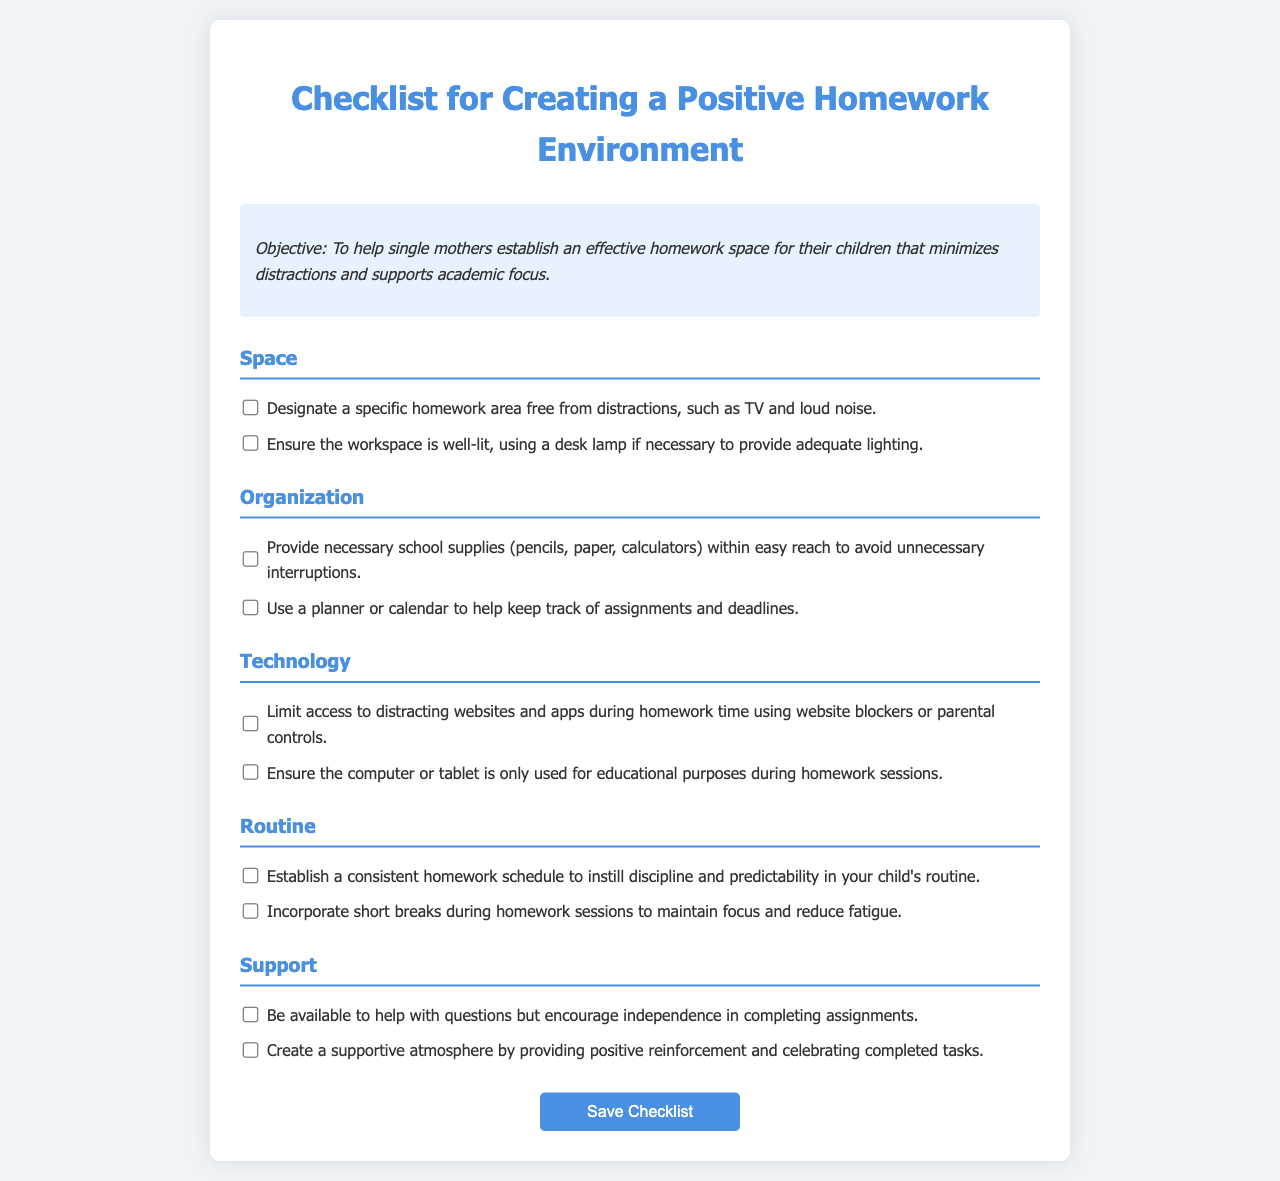What is the objective of the checklist? The objective is to help single mothers establish an effective homework space for their children that minimizes distractions and supports academic focus.
Answer: To help single mothers establish an effective homework space for their children that minimizes distractions and supports academic focus How many categories are included in the checklist? The checklist includes five categories: Space, Organization, Technology, Routine, and Support.
Answer: Five Which category contains the recommendation about using a planner? The recommendation about using a planner is found in the Organization category.
Answer: Organization What should be ensured about the workspace lighting? The workspace should be well-lit, using a desk lamp if necessary to provide adequate lighting.
Answer: Well-lit, using a desk lamp if necessary to provide adequate lighting What is one way to create a supportive atmosphere? One way to create a supportive atmosphere is by providing positive reinforcement and celebrating completed tasks.
Answer: Providing positive reinforcement and celebrating completed tasks What does the routine category suggest about breaks? The routine category suggests incorporating short breaks during homework sessions to maintain focus and reduce fatigue.
Answer: Incorporating short breaks during homework sessions What feature does the submit button have? The submit button has a hover effect that changes its background color.
Answer: Hover effect that changes its background color How many recommendations are provided under the Space category? There are two recommendations provided under the Space category.
Answer: Two 